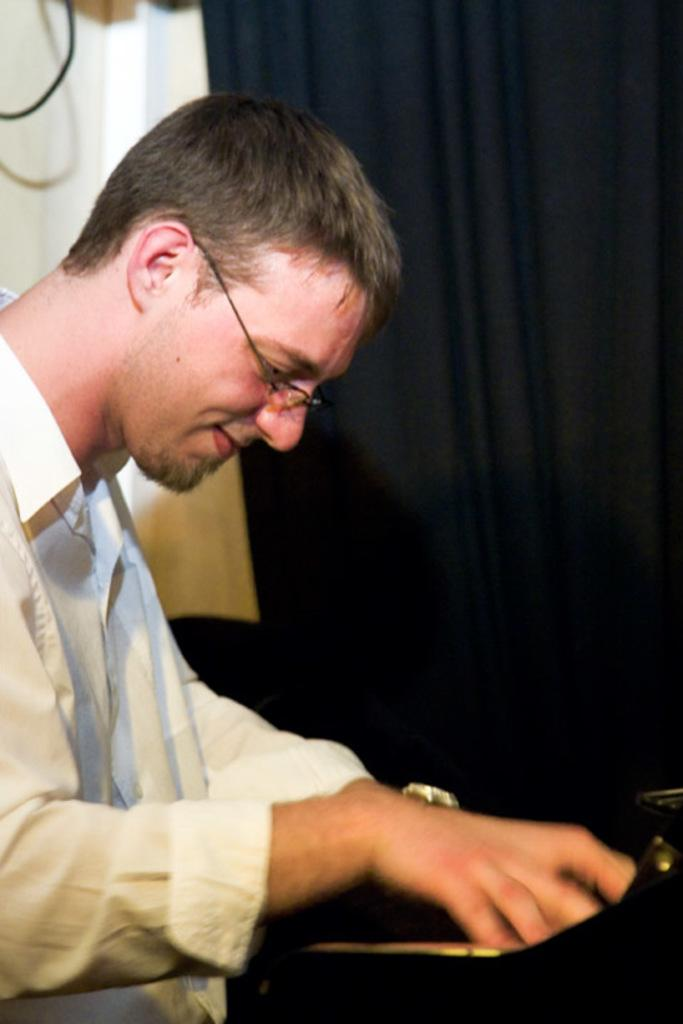What is the main subject of the picture? The main subject of the picture is a person. What is the person doing in the picture? The person is smiling in the picture. What accessory is the person wearing in the picture? The person is wearing spectacles in the picture. What type of branch can be seen in the person's hand in the image? There is no branch present in the image; the person is not holding anything. 